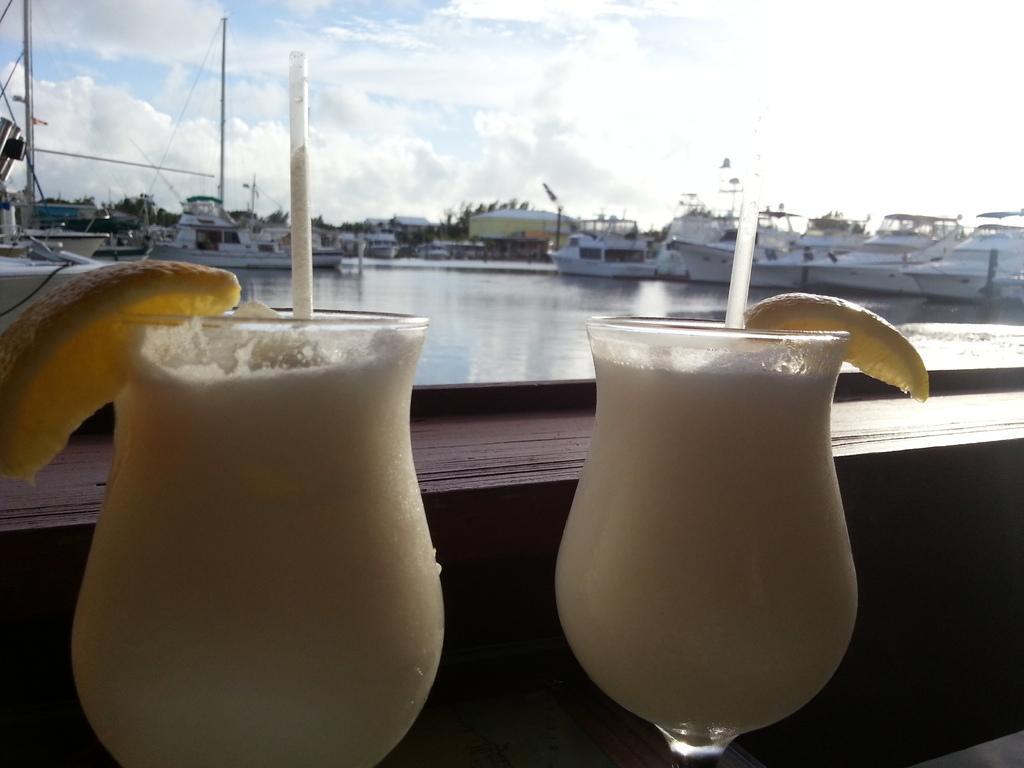Could you give a brief overview of what you see in this image? In this image I can see there are two juice glasses with lemon slices on them, at the back side there are boats in this water. At the top it is the cloudy sky, 